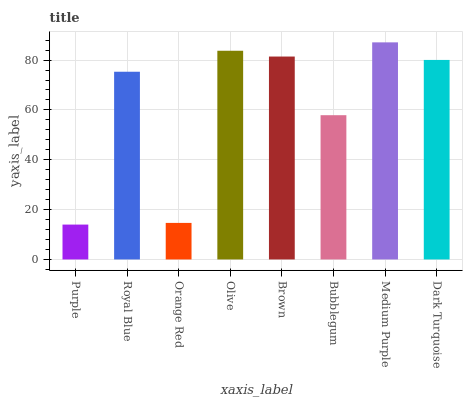Is Purple the minimum?
Answer yes or no. Yes. Is Medium Purple the maximum?
Answer yes or no. Yes. Is Royal Blue the minimum?
Answer yes or no. No. Is Royal Blue the maximum?
Answer yes or no. No. Is Royal Blue greater than Purple?
Answer yes or no. Yes. Is Purple less than Royal Blue?
Answer yes or no. Yes. Is Purple greater than Royal Blue?
Answer yes or no. No. Is Royal Blue less than Purple?
Answer yes or no. No. Is Dark Turquoise the high median?
Answer yes or no. Yes. Is Royal Blue the low median?
Answer yes or no. Yes. Is Bubblegum the high median?
Answer yes or no. No. Is Bubblegum the low median?
Answer yes or no. No. 